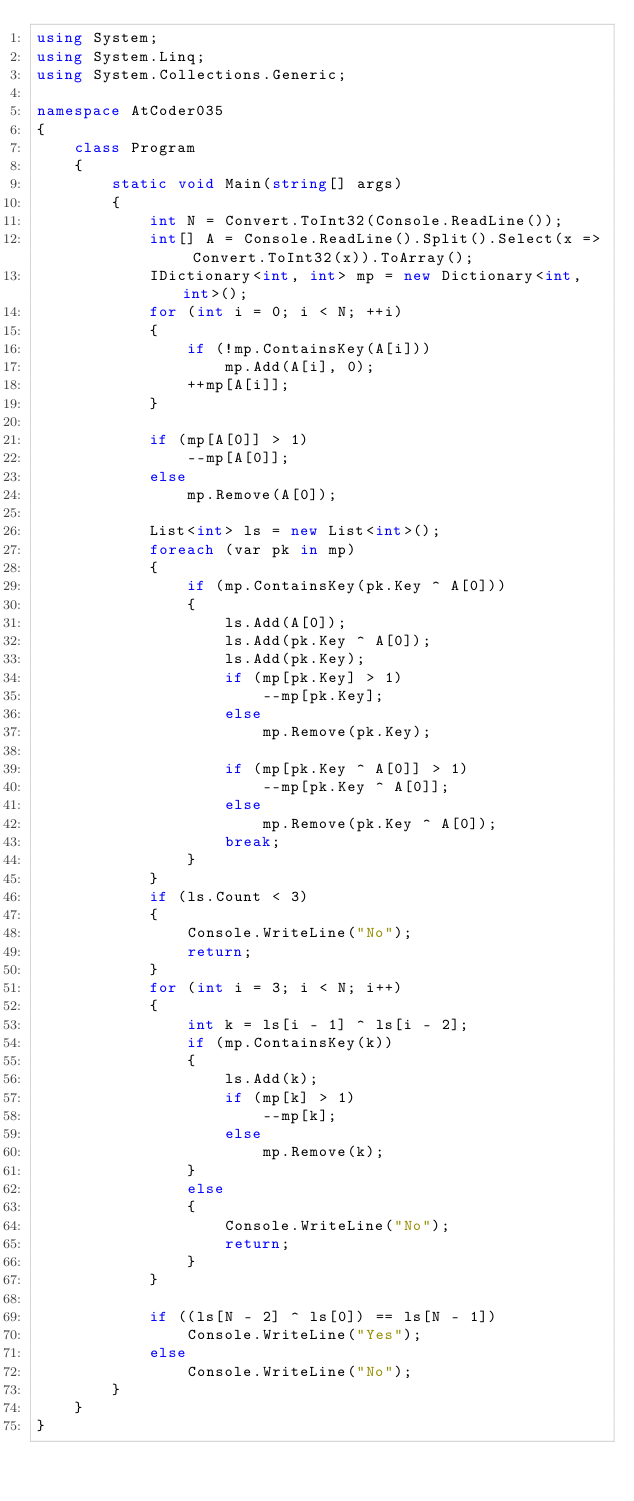Convert code to text. <code><loc_0><loc_0><loc_500><loc_500><_C#_>using System;
using System.Linq;
using System.Collections.Generic;

namespace AtCoder035
{
    class Program
    {
        static void Main(string[] args)
        {
            int N = Convert.ToInt32(Console.ReadLine());
            int[] A = Console.ReadLine().Split().Select(x => Convert.ToInt32(x)).ToArray();
            IDictionary<int, int> mp = new Dictionary<int, int>();
            for (int i = 0; i < N; ++i)
            {
                if (!mp.ContainsKey(A[i]))
                    mp.Add(A[i], 0);
                ++mp[A[i]];
            }

            if (mp[A[0]] > 1)
                --mp[A[0]];
            else
                mp.Remove(A[0]);

            List<int> ls = new List<int>();
            foreach (var pk in mp)
            {
                if (mp.ContainsKey(pk.Key ^ A[0]))
                {
                    ls.Add(A[0]);
                    ls.Add(pk.Key ^ A[0]);
                    ls.Add(pk.Key);
                    if (mp[pk.Key] > 1)
                        --mp[pk.Key];
                    else
                        mp.Remove(pk.Key);

                    if (mp[pk.Key ^ A[0]] > 1)
                        --mp[pk.Key ^ A[0]];
                    else
                        mp.Remove(pk.Key ^ A[0]);
                    break;
                }
            }
            if (ls.Count < 3)
            {
                Console.WriteLine("No");
                return;
            }
            for (int i = 3; i < N; i++)
            {
                int k = ls[i - 1] ^ ls[i - 2];
                if (mp.ContainsKey(k))
                {
                    ls.Add(k);
                    if (mp[k] > 1)
                        --mp[k];
                    else
                        mp.Remove(k);
                }
                else
                {
                    Console.WriteLine("No");
                    return;
                }
            }

            if ((ls[N - 2] ^ ls[0]) == ls[N - 1])
                Console.WriteLine("Yes");
            else
                Console.WriteLine("No");
        }
    }
}</code> 